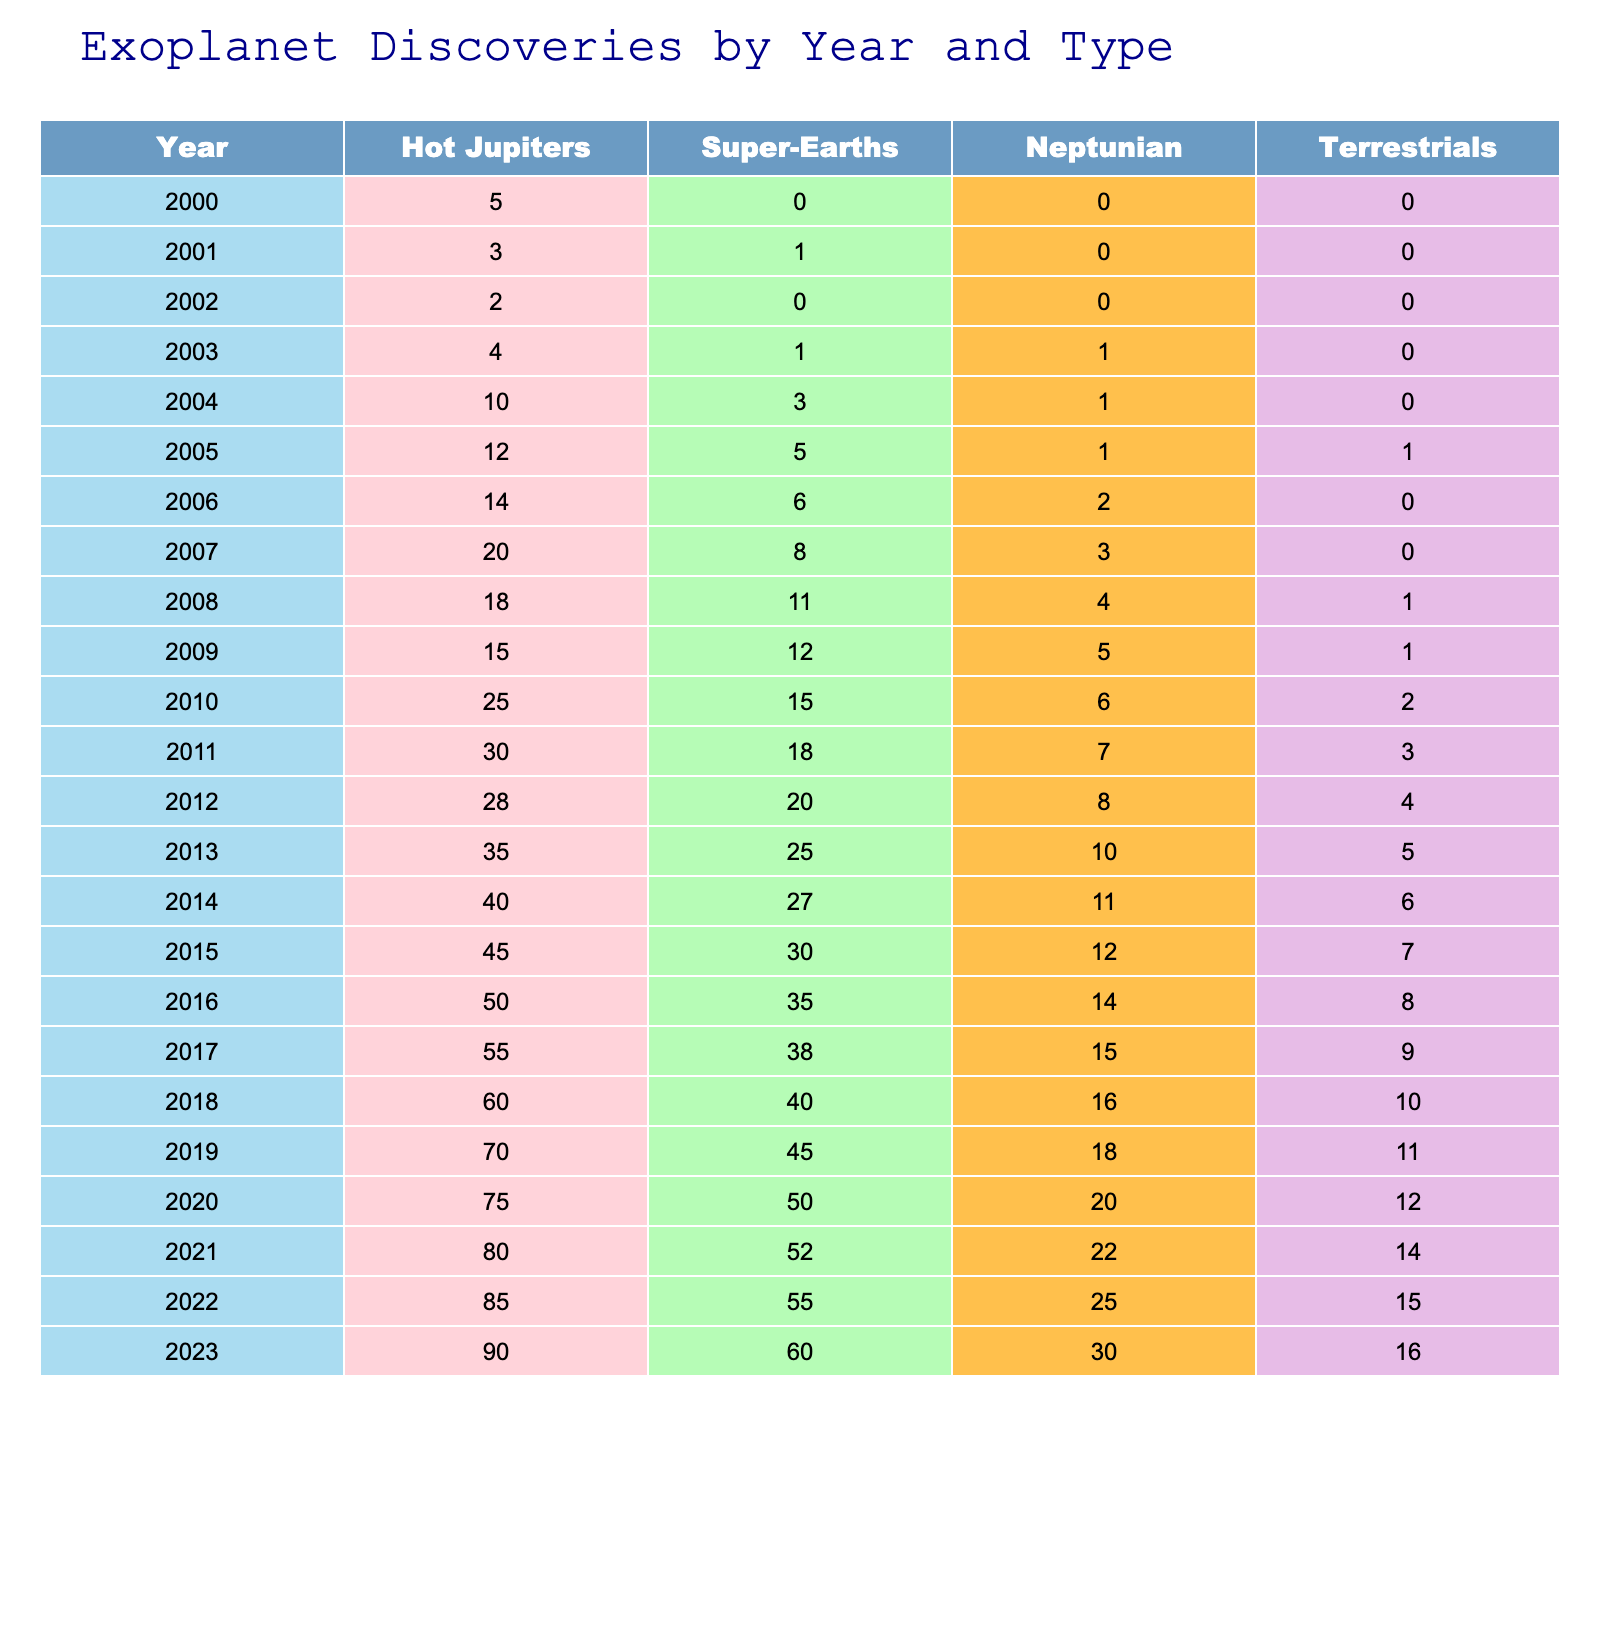What was the total number of Super-Earths discovered by 2010? To find the total number of Super-Earths discovered by 2010, I add the values from each year from 2000 to 2010: 0 (2000) + 1 (2001) + 0 (2002) + 1 (2003) + 3 (2004) + 5 (2005) + 6 (2006) + 8 (2007) + 11 (2008) + 12 (2009) + 15 (2010) = 62.
Answer: 62 In which year did the number of Hot Jupiters first exceed 50? From the table, I look for the first year where the number of Hot Jupiters is greater than 50. Counting through the years, I find that in 2016, the count reached 50, and it exceeded this in 2017, which recorded 55.
Answer: 2017 What is the average number of Neptunian discoveries per year from 2000 to 2023? To find the average, I first sum the Neptunian discoveries from each year (0 + 0 + 0 + 1 + 1 + 1 + 2 + 3 + 4 + 5 + 6 + 7 + 8 + 10 + 11 + 12 + 14 + 15 + 16 + 18 + 20 + 22 + 25 + 30 =  38). Then I divide this by the total number of years (2023 - 2000 + 1 = 24): 38/24 = 1.58.
Answer: 1.58 Did more Terrestrials or Super-Earths get discovered in 2015? I can directly compare the values from 2015 in the table: for Super-Earths, there were 30 discoveries, while for Terrestrials, there were 7. Therefore, more Super-Earths than Terrestrials were discovered in 2015.
Answer: Yes What is the percentage increase in Hot Jupiters from 2010 to 2023? To calculate the percentage increase, I first find the difference between the number of Hot Jupiters in 2023 (90) and in 2010 (25), which is 90 - 25 = 65. Then, I divide the difference by the 2010 figure and multiply by 100 to get the percentage: (65/25) * 100 = 260%.
Answer: 260% 